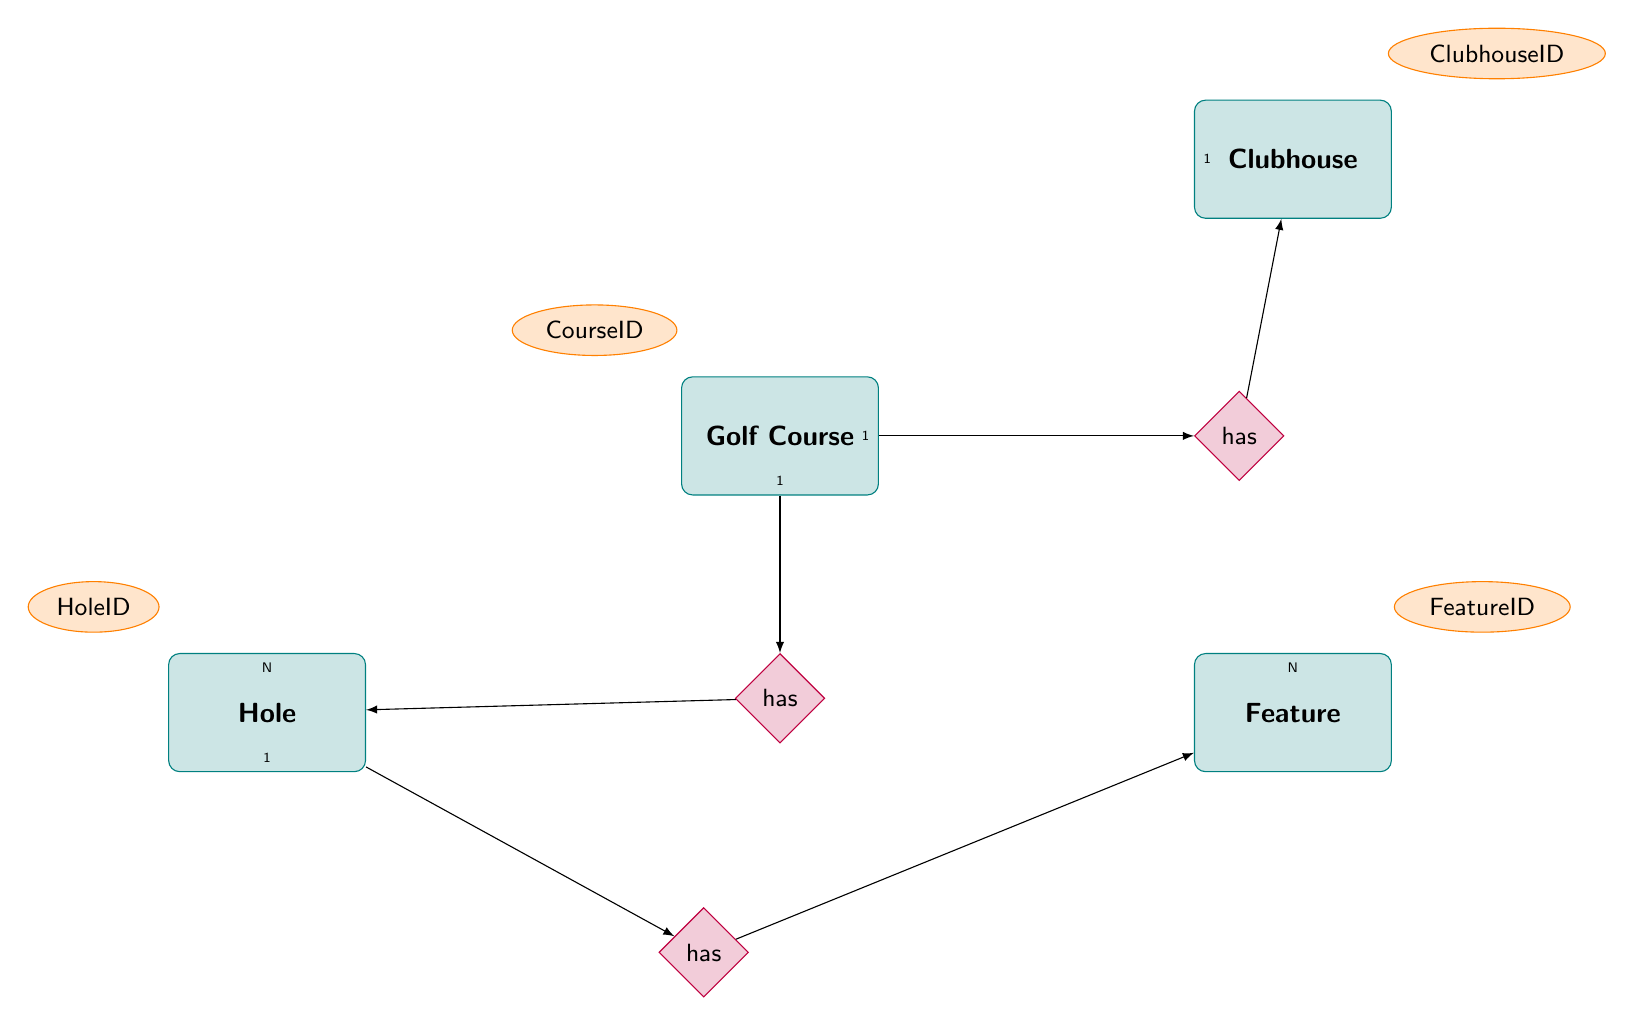What entity represents the overall golf facility? The entity that represents the overall golf facility in the diagram is "Golf Course," which is a high-level entity that encompasses all features and components related to the golf property.
Answer: Golf Course How many holes are associated with a golf course? The diagram indicates a one-to-many relationship between "Golf Course" and "Hole," meaning that one golf course can have multiple holes. Therefore, the number of holes can vary.
Answer: N What feature type is included in the hole feature relationship? The "HoleFeature" entity is linked to the "Feature" entity through an included relationship. This indicates that features such as water hazards or sand traps can be associated with specific holes.
Answer: Feature What is the relationship between Golf Course and Clubhouse? The relationship is depicted as a one-to-one relationship, meaning each golf course is associated with exactly one clubhouse, showcasing the link between the two entities.
Answer: has Which entity has an ID that connects holes to their specific features? The "HoleFeature" entity serves as an associative entity that links "Hole" and "Feature," including IDs for holes and their respective features, indicating the relationship between them.
Answer: HoleFeature What is the cardinality of the holes related to the features? The relationship shows that there is a one-to-many relationship from "Hole" to "HoleFeature," which implies each hole can have multiple features associated with it, while each feature can belong to only one hole.
Answer: 1 to N Is there a specific clubhouse for each golf course? Yes, the diagram illustrates that the "Golf Course" has a one-to-one relationship with "Clubhouse," confirming that each golf course is associated with one specific clubhouse.
Answer: Yes 